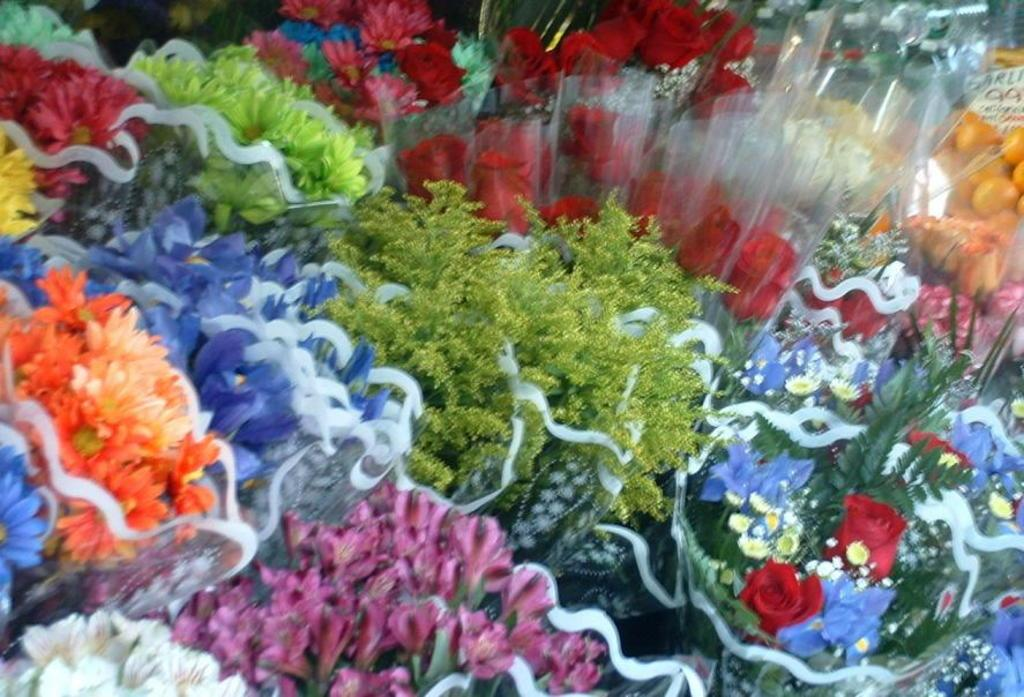What type of objects are present in the image? There are flower bouquets in the image. Can you describe the colors of the bouquets? The bouquets have various colors, including yellow, blue, pink, green, and orange. How does the fog affect the waste in the image? There is no fog or waste present in the image; it only features flower bouquets with various colors. 